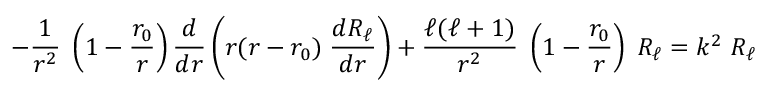Convert formula to latex. <formula><loc_0><loc_0><loc_500><loc_500>- { \frac { 1 } { r ^ { 2 } } } \, \left ( 1 - { \frac { r _ { 0 } } { r } } \right ) { \frac { d } { d r } } \left ( r ( r - r _ { 0 } ) \, { \frac { d R _ { \ell } } { d r } } \right ) + { \frac { \ell ( \ell + 1 ) } { r ^ { 2 } } } \, \left ( 1 - { \frac { r _ { 0 } } { r } } \right ) \, R _ { \ell } = k ^ { 2 } \, R _ { \ell }</formula> 